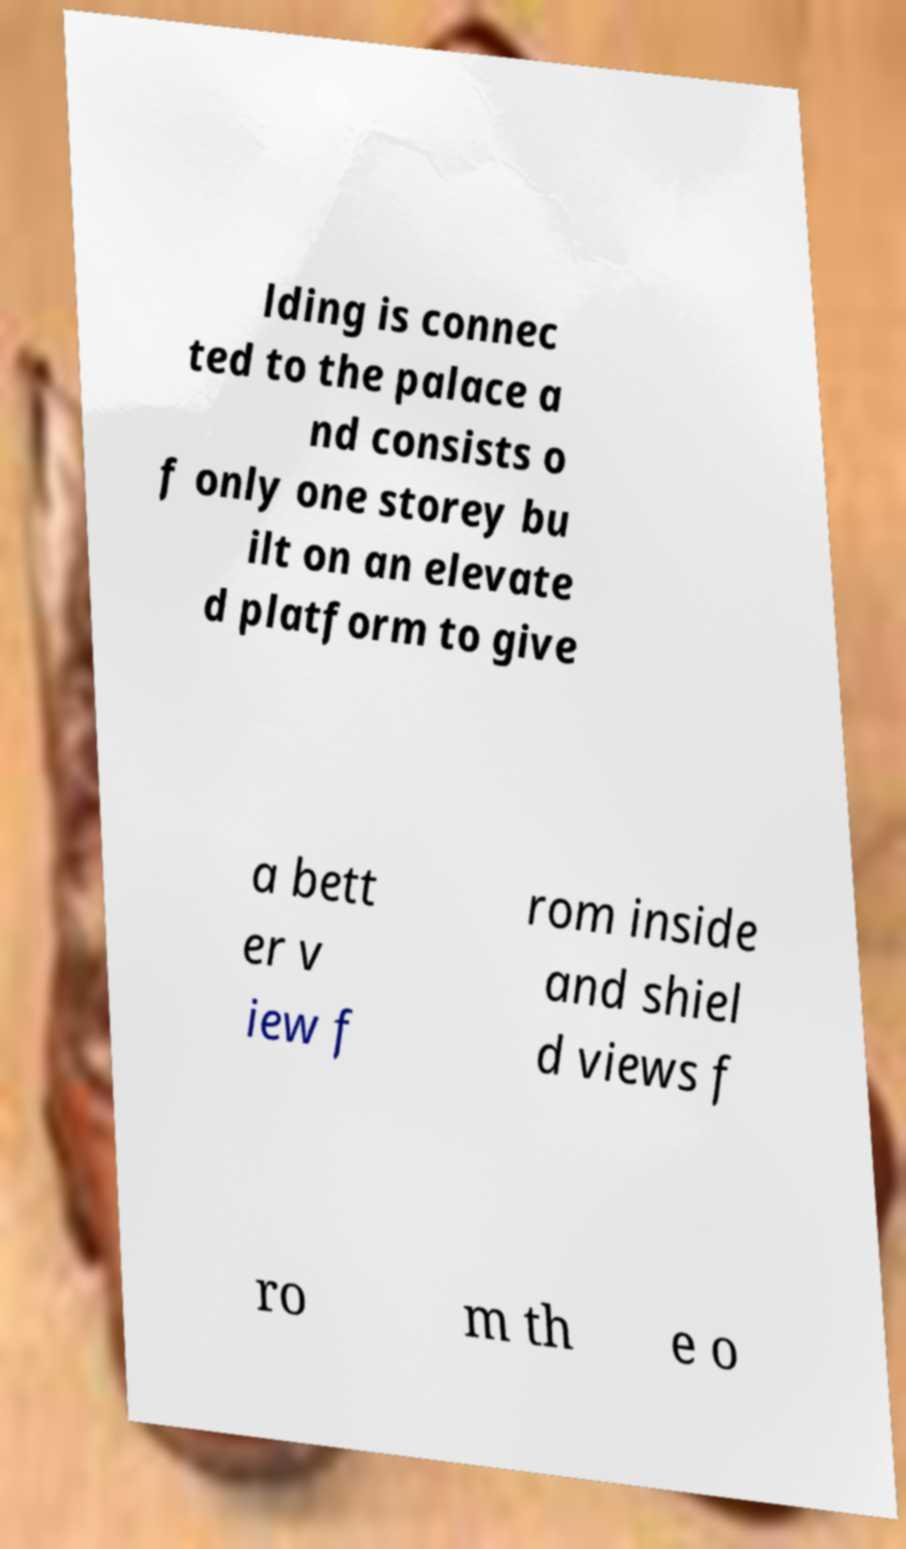What messages or text are displayed in this image? I need them in a readable, typed format. lding is connec ted to the palace a nd consists o f only one storey bu ilt on an elevate d platform to give a bett er v iew f rom inside and shiel d views f ro m th e o 